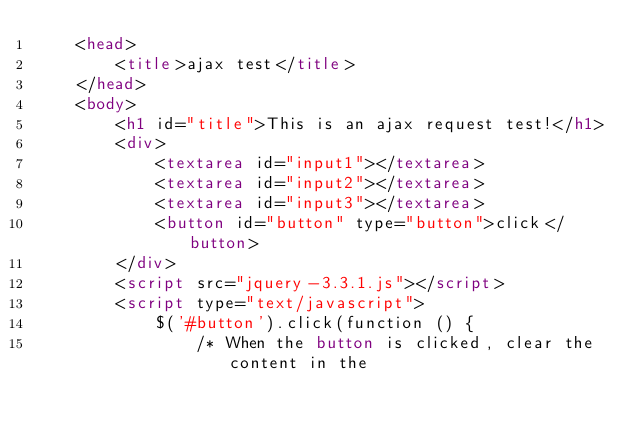<code> <loc_0><loc_0><loc_500><loc_500><_HTML_>    <head>
        <title>ajax test</title>
    </head>
    <body>
        <h1 id="title">This is an ajax request test!</h1>
        <div>
            <textarea id="input1"></textarea>
            <textarea id="input2"></textarea>
            <textarea id="input3"></textarea>
            <button id="button" type="button">click</button>
        </div>
        <script src="jquery-3.3.1.js"></script>
        <script type="text/javascript">
            $('#button').click(function () {
                /* When the button is clicked, clear the content in the</code> 